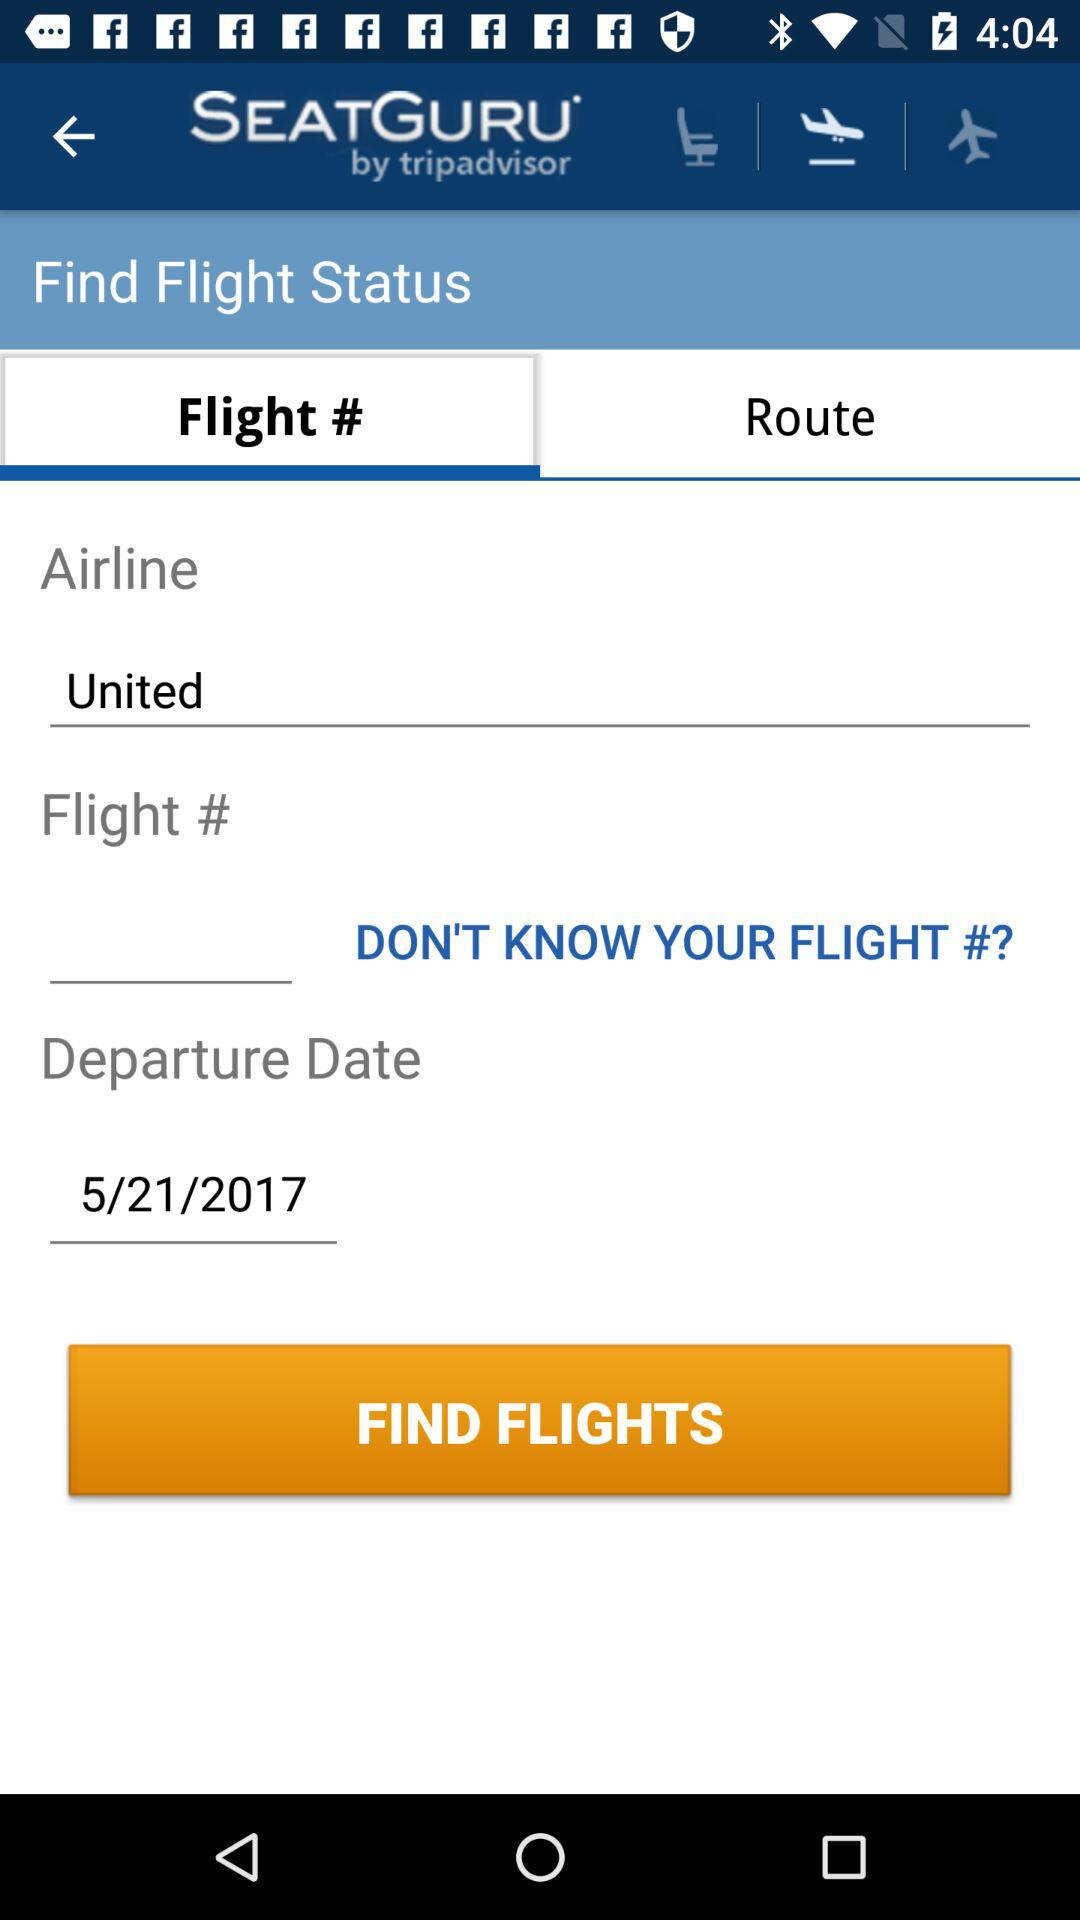What is the name of the application? The name of the application is "SEATGURU". 